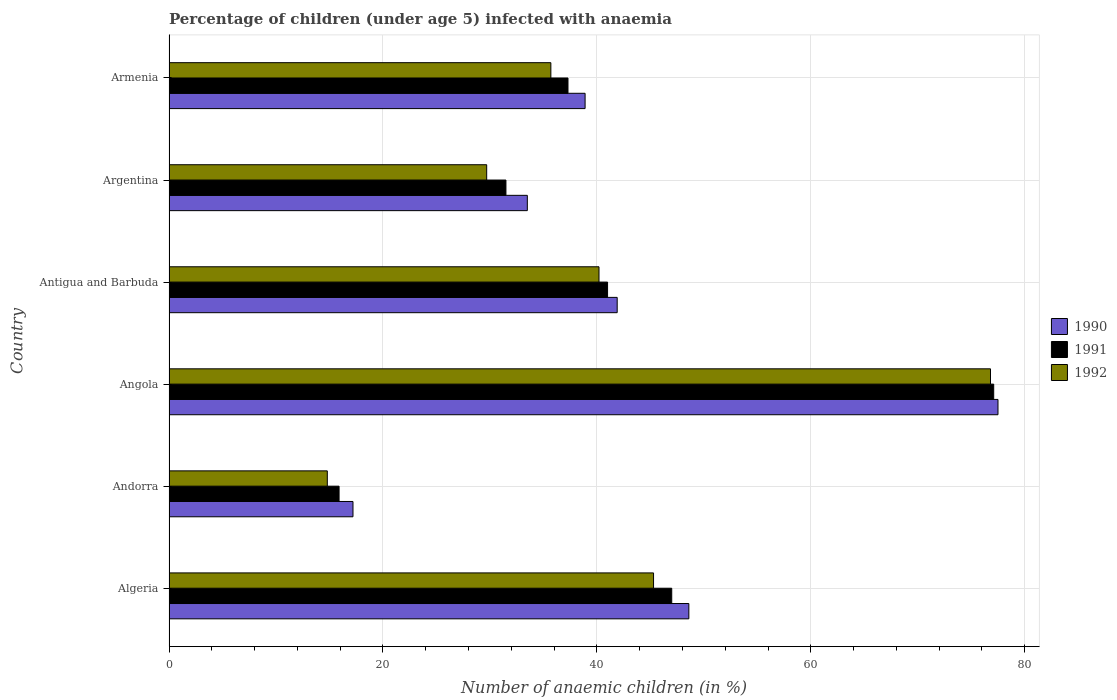How many groups of bars are there?
Your answer should be very brief. 6. How many bars are there on the 6th tick from the top?
Give a very brief answer. 3. What is the percentage of children infected with anaemia in in 1992 in Argentina?
Make the answer very short. 29.7. Across all countries, what is the maximum percentage of children infected with anaemia in in 1992?
Offer a terse response. 76.8. Across all countries, what is the minimum percentage of children infected with anaemia in in 1990?
Keep it short and to the point. 17.2. In which country was the percentage of children infected with anaemia in in 1990 maximum?
Keep it short and to the point. Angola. In which country was the percentage of children infected with anaemia in in 1992 minimum?
Provide a short and direct response. Andorra. What is the total percentage of children infected with anaemia in in 1990 in the graph?
Offer a very short reply. 257.6. What is the difference between the percentage of children infected with anaemia in in 1990 in Algeria and that in Armenia?
Provide a short and direct response. 9.7. What is the difference between the percentage of children infected with anaemia in in 1992 in Antigua and Barbuda and the percentage of children infected with anaemia in in 1990 in Angola?
Make the answer very short. -37.3. What is the average percentage of children infected with anaemia in in 1991 per country?
Give a very brief answer. 41.63. What is the difference between the percentage of children infected with anaemia in in 1990 and percentage of children infected with anaemia in in 1991 in Antigua and Barbuda?
Give a very brief answer. 0.9. In how many countries, is the percentage of children infected with anaemia in in 1990 greater than 24 %?
Give a very brief answer. 5. What is the ratio of the percentage of children infected with anaemia in in 1990 in Andorra to that in Angola?
Ensure brevity in your answer.  0.22. What is the difference between the highest and the second highest percentage of children infected with anaemia in in 1991?
Give a very brief answer. 30.1. What is the difference between the highest and the lowest percentage of children infected with anaemia in in 1991?
Your answer should be very brief. 61.2. In how many countries, is the percentage of children infected with anaemia in in 1992 greater than the average percentage of children infected with anaemia in in 1992 taken over all countries?
Make the answer very short. 2. What does the 1st bar from the top in Angola represents?
Provide a short and direct response. 1992. How many bars are there?
Keep it short and to the point. 18. How many countries are there in the graph?
Give a very brief answer. 6. Does the graph contain any zero values?
Offer a terse response. No. Does the graph contain grids?
Your response must be concise. Yes. Where does the legend appear in the graph?
Keep it short and to the point. Center right. How many legend labels are there?
Ensure brevity in your answer.  3. How are the legend labels stacked?
Your response must be concise. Vertical. What is the title of the graph?
Give a very brief answer. Percentage of children (under age 5) infected with anaemia. What is the label or title of the X-axis?
Your answer should be very brief. Number of anaemic children (in %). What is the Number of anaemic children (in %) of 1990 in Algeria?
Offer a terse response. 48.6. What is the Number of anaemic children (in %) of 1991 in Algeria?
Ensure brevity in your answer.  47. What is the Number of anaemic children (in %) in 1992 in Algeria?
Your answer should be compact. 45.3. What is the Number of anaemic children (in %) in 1990 in Andorra?
Provide a short and direct response. 17.2. What is the Number of anaemic children (in %) in 1991 in Andorra?
Your response must be concise. 15.9. What is the Number of anaemic children (in %) in 1990 in Angola?
Make the answer very short. 77.5. What is the Number of anaemic children (in %) of 1991 in Angola?
Your answer should be compact. 77.1. What is the Number of anaemic children (in %) in 1992 in Angola?
Make the answer very short. 76.8. What is the Number of anaemic children (in %) of 1990 in Antigua and Barbuda?
Ensure brevity in your answer.  41.9. What is the Number of anaemic children (in %) of 1991 in Antigua and Barbuda?
Offer a very short reply. 41. What is the Number of anaemic children (in %) of 1992 in Antigua and Barbuda?
Offer a terse response. 40.2. What is the Number of anaemic children (in %) in 1990 in Argentina?
Your answer should be compact. 33.5. What is the Number of anaemic children (in %) of 1991 in Argentina?
Your answer should be very brief. 31.5. What is the Number of anaemic children (in %) in 1992 in Argentina?
Keep it short and to the point. 29.7. What is the Number of anaemic children (in %) in 1990 in Armenia?
Offer a very short reply. 38.9. What is the Number of anaemic children (in %) in 1991 in Armenia?
Ensure brevity in your answer.  37.3. What is the Number of anaemic children (in %) in 1992 in Armenia?
Provide a succinct answer. 35.7. Across all countries, what is the maximum Number of anaemic children (in %) of 1990?
Provide a succinct answer. 77.5. Across all countries, what is the maximum Number of anaemic children (in %) in 1991?
Make the answer very short. 77.1. Across all countries, what is the maximum Number of anaemic children (in %) in 1992?
Provide a succinct answer. 76.8. What is the total Number of anaemic children (in %) of 1990 in the graph?
Give a very brief answer. 257.6. What is the total Number of anaemic children (in %) of 1991 in the graph?
Make the answer very short. 249.8. What is the total Number of anaemic children (in %) in 1992 in the graph?
Offer a very short reply. 242.5. What is the difference between the Number of anaemic children (in %) of 1990 in Algeria and that in Andorra?
Your answer should be compact. 31.4. What is the difference between the Number of anaemic children (in %) of 1991 in Algeria and that in Andorra?
Your answer should be very brief. 31.1. What is the difference between the Number of anaemic children (in %) of 1992 in Algeria and that in Andorra?
Give a very brief answer. 30.5. What is the difference between the Number of anaemic children (in %) of 1990 in Algeria and that in Angola?
Offer a terse response. -28.9. What is the difference between the Number of anaemic children (in %) in 1991 in Algeria and that in Angola?
Provide a short and direct response. -30.1. What is the difference between the Number of anaemic children (in %) of 1992 in Algeria and that in Angola?
Provide a short and direct response. -31.5. What is the difference between the Number of anaemic children (in %) of 1991 in Algeria and that in Antigua and Barbuda?
Your answer should be very brief. 6. What is the difference between the Number of anaemic children (in %) of 1990 in Algeria and that in Argentina?
Your answer should be compact. 15.1. What is the difference between the Number of anaemic children (in %) in 1991 in Algeria and that in Argentina?
Make the answer very short. 15.5. What is the difference between the Number of anaemic children (in %) of 1992 in Algeria and that in Argentina?
Make the answer very short. 15.6. What is the difference between the Number of anaemic children (in %) of 1990 in Algeria and that in Armenia?
Your response must be concise. 9.7. What is the difference between the Number of anaemic children (in %) in 1991 in Algeria and that in Armenia?
Offer a terse response. 9.7. What is the difference between the Number of anaemic children (in %) of 1992 in Algeria and that in Armenia?
Provide a short and direct response. 9.6. What is the difference between the Number of anaemic children (in %) in 1990 in Andorra and that in Angola?
Offer a very short reply. -60.3. What is the difference between the Number of anaemic children (in %) of 1991 in Andorra and that in Angola?
Your response must be concise. -61.2. What is the difference between the Number of anaemic children (in %) in 1992 in Andorra and that in Angola?
Offer a terse response. -62. What is the difference between the Number of anaemic children (in %) of 1990 in Andorra and that in Antigua and Barbuda?
Keep it short and to the point. -24.7. What is the difference between the Number of anaemic children (in %) of 1991 in Andorra and that in Antigua and Barbuda?
Keep it short and to the point. -25.1. What is the difference between the Number of anaemic children (in %) of 1992 in Andorra and that in Antigua and Barbuda?
Offer a terse response. -25.4. What is the difference between the Number of anaemic children (in %) in 1990 in Andorra and that in Argentina?
Keep it short and to the point. -16.3. What is the difference between the Number of anaemic children (in %) in 1991 in Andorra and that in Argentina?
Offer a terse response. -15.6. What is the difference between the Number of anaemic children (in %) of 1992 in Andorra and that in Argentina?
Offer a terse response. -14.9. What is the difference between the Number of anaemic children (in %) in 1990 in Andorra and that in Armenia?
Make the answer very short. -21.7. What is the difference between the Number of anaemic children (in %) of 1991 in Andorra and that in Armenia?
Ensure brevity in your answer.  -21.4. What is the difference between the Number of anaemic children (in %) of 1992 in Andorra and that in Armenia?
Keep it short and to the point. -20.9. What is the difference between the Number of anaemic children (in %) of 1990 in Angola and that in Antigua and Barbuda?
Your answer should be very brief. 35.6. What is the difference between the Number of anaemic children (in %) of 1991 in Angola and that in Antigua and Barbuda?
Provide a short and direct response. 36.1. What is the difference between the Number of anaemic children (in %) in 1992 in Angola and that in Antigua and Barbuda?
Provide a short and direct response. 36.6. What is the difference between the Number of anaemic children (in %) in 1991 in Angola and that in Argentina?
Provide a short and direct response. 45.6. What is the difference between the Number of anaemic children (in %) of 1992 in Angola and that in Argentina?
Provide a succinct answer. 47.1. What is the difference between the Number of anaemic children (in %) in 1990 in Angola and that in Armenia?
Offer a very short reply. 38.6. What is the difference between the Number of anaemic children (in %) in 1991 in Angola and that in Armenia?
Make the answer very short. 39.8. What is the difference between the Number of anaemic children (in %) in 1992 in Angola and that in Armenia?
Provide a succinct answer. 41.1. What is the difference between the Number of anaemic children (in %) of 1990 in Antigua and Barbuda and that in Argentina?
Provide a short and direct response. 8.4. What is the difference between the Number of anaemic children (in %) of 1991 in Antigua and Barbuda and that in Argentina?
Keep it short and to the point. 9.5. What is the difference between the Number of anaemic children (in %) of 1992 in Antigua and Barbuda and that in Argentina?
Give a very brief answer. 10.5. What is the difference between the Number of anaemic children (in %) of 1990 in Antigua and Barbuda and that in Armenia?
Your answer should be very brief. 3. What is the difference between the Number of anaemic children (in %) in 1991 in Antigua and Barbuda and that in Armenia?
Keep it short and to the point. 3.7. What is the difference between the Number of anaemic children (in %) of 1992 in Argentina and that in Armenia?
Your answer should be very brief. -6. What is the difference between the Number of anaemic children (in %) in 1990 in Algeria and the Number of anaemic children (in %) in 1991 in Andorra?
Provide a short and direct response. 32.7. What is the difference between the Number of anaemic children (in %) of 1990 in Algeria and the Number of anaemic children (in %) of 1992 in Andorra?
Offer a terse response. 33.8. What is the difference between the Number of anaemic children (in %) in 1991 in Algeria and the Number of anaemic children (in %) in 1992 in Andorra?
Make the answer very short. 32.2. What is the difference between the Number of anaemic children (in %) of 1990 in Algeria and the Number of anaemic children (in %) of 1991 in Angola?
Give a very brief answer. -28.5. What is the difference between the Number of anaemic children (in %) in 1990 in Algeria and the Number of anaemic children (in %) in 1992 in Angola?
Make the answer very short. -28.2. What is the difference between the Number of anaemic children (in %) of 1991 in Algeria and the Number of anaemic children (in %) of 1992 in Angola?
Your answer should be compact. -29.8. What is the difference between the Number of anaemic children (in %) in 1990 in Algeria and the Number of anaemic children (in %) in 1991 in Antigua and Barbuda?
Give a very brief answer. 7.6. What is the difference between the Number of anaemic children (in %) of 1990 in Algeria and the Number of anaemic children (in %) of 1992 in Antigua and Barbuda?
Offer a very short reply. 8.4. What is the difference between the Number of anaemic children (in %) of 1990 in Algeria and the Number of anaemic children (in %) of 1991 in Argentina?
Provide a short and direct response. 17.1. What is the difference between the Number of anaemic children (in %) of 1991 in Algeria and the Number of anaemic children (in %) of 1992 in Argentina?
Offer a terse response. 17.3. What is the difference between the Number of anaemic children (in %) in 1990 in Andorra and the Number of anaemic children (in %) in 1991 in Angola?
Your answer should be very brief. -59.9. What is the difference between the Number of anaemic children (in %) in 1990 in Andorra and the Number of anaemic children (in %) in 1992 in Angola?
Offer a very short reply. -59.6. What is the difference between the Number of anaemic children (in %) of 1991 in Andorra and the Number of anaemic children (in %) of 1992 in Angola?
Give a very brief answer. -60.9. What is the difference between the Number of anaemic children (in %) of 1990 in Andorra and the Number of anaemic children (in %) of 1991 in Antigua and Barbuda?
Make the answer very short. -23.8. What is the difference between the Number of anaemic children (in %) of 1990 in Andorra and the Number of anaemic children (in %) of 1992 in Antigua and Barbuda?
Ensure brevity in your answer.  -23. What is the difference between the Number of anaemic children (in %) of 1991 in Andorra and the Number of anaemic children (in %) of 1992 in Antigua and Barbuda?
Offer a very short reply. -24.3. What is the difference between the Number of anaemic children (in %) of 1990 in Andorra and the Number of anaemic children (in %) of 1991 in Argentina?
Offer a terse response. -14.3. What is the difference between the Number of anaemic children (in %) of 1990 in Andorra and the Number of anaemic children (in %) of 1991 in Armenia?
Give a very brief answer. -20.1. What is the difference between the Number of anaemic children (in %) in 1990 in Andorra and the Number of anaemic children (in %) in 1992 in Armenia?
Offer a terse response. -18.5. What is the difference between the Number of anaemic children (in %) of 1991 in Andorra and the Number of anaemic children (in %) of 1992 in Armenia?
Keep it short and to the point. -19.8. What is the difference between the Number of anaemic children (in %) in 1990 in Angola and the Number of anaemic children (in %) in 1991 in Antigua and Barbuda?
Offer a very short reply. 36.5. What is the difference between the Number of anaemic children (in %) of 1990 in Angola and the Number of anaemic children (in %) of 1992 in Antigua and Barbuda?
Offer a terse response. 37.3. What is the difference between the Number of anaemic children (in %) in 1991 in Angola and the Number of anaemic children (in %) in 1992 in Antigua and Barbuda?
Your answer should be very brief. 36.9. What is the difference between the Number of anaemic children (in %) of 1990 in Angola and the Number of anaemic children (in %) of 1992 in Argentina?
Offer a very short reply. 47.8. What is the difference between the Number of anaemic children (in %) in 1991 in Angola and the Number of anaemic children (in %) in 1992 in Argentina?
Keep it short and to the point. 47.4. What is the difference between the Number of anaemic children (in %) in 1990 in Angola and the Number of anaemic children (in %) in 1991 in Armenia?
Your response must be concise. 40.2. What is the difference between the Number of anaemic children (in %) of 1990 in Angola and the Number of anaemic children (in %) of 1992 in Armenia?
Give a very brief answer. 41.8. What is the difference between the Number of anaemic children (in %) of 1991 in Angola and the Number of anaemic children (in %) of 1992 in Armenia?
Your answer should be very brief. 41.4. What is the difference between the Number of anaemic children (in %) of 1990 in Antigua and Barbuda and the Number of anaemic children (in %) of 1992 in Argentina?
Your response must be concise. 12.2. What is the difference between the Number of anaemic children (in %) of 1990 in Antigua and Barbuda and the Number of anaemic children (in %) of 1992 in Armenia?
Your answer should be compact. 6.2. What is the difference between the Number of anaemic children (in %) in 1990 in Argentina and the Number of anaemic children (in %) in 1991 in Armenia?
Your response must be concise. -3.8. What is the difference between the Number of anaemic children (in %) of 1991 in Argentina and the Number of anaemic children (in %) of 1992 in Armenia?
Ensure brevity in your answer.  -4.2. What is the average Number of anaemic children (in %) in 1990 per country?
Offer a very short reply. 42.93. What is the average Number of anaemic children (in %) in 1991 per country?
Provide a short and direct response. 41.63. What is the average Number of anaemic children (in %) in 1992 per country?
Make the answer very short. 40.42. What is the difference between the Number of anaemic children (in %) in 1991 and Number of anaemic children (in %) in 1992 in Algeria?
Provide a succinct answer. 1.7. What is the difference between the Number of anaemic children (in %) of 1990 and Number of anaemic children (in %) of 1991 in Andorra?
Provide a succinct answer. 1.3. What is the difference between the Number of anaemic children (in %) in 1990 and Number of anaemic children (in %) in 1991 in Antigua and Barbuda?
Your response must be concise. 0.9. What is the difference between the Number of anaemic children (in %) in 1990 and Number of anaemic children (in %) in 1992 in Antigua and Barbuda?
Keep it short and to the point. 1.7. What is the difference between the Number of anaemic children (in %) of 1991 and Number of anaemic children (in %) of 1992 in Argentina?
Make the answer very short. 1.8. What is the difference between the Number of anaemic children (in %) in 1990 and Number of anaemic children (in %) in 1991 in Armenia?
Make the answer very short. 1.6. What is the difference between the Number of anaemic children (in %) of 1990 and Number of anaemic children (in %) of 1992 in Armenia?
Give a very brief answer. 3.2. What is the ratio of the Number of anaemic children (in %) in 1990 in Algeria to that in Andorra?
Provide a succinct answer. 2.83. What is the ratio of the Number of anaemic children (in %) of 1991 in Algeria to that in Andorra?
Your response must be concise. 2.96. What is the ratio of the Number of anaemic children (in %) of 1992 in Algeria to that in Andorra?
Provide a short and direct response. 3.06. What is the ratio of the Number of anaemic children (in %) of 1990 in Algeria to that in Angola?
Ensure brevity in your answer.  0.63. What is the ratio of the Number of anaemic children (in %) of 1991 in Algeria to that in Angola?
Your answer should be compact. 0.61. What is the ratio of the Number of anaemic children (in %) of 1992 in Algeria to that in Angola?
Your answer should be compact. 0.59. What is the ratio of the Number of anaemic children (in %) in 1990 in Algeria to that in Antigua and Barbuda?
Your response must be concise. 1.16. What is the ratio of the Number of anaemic children (in %) in 1991 in Algeria to that in Antigua and Barbuda?
Provide a short and direct response. 1.15. What is the ratio of the Number of anaemic children (in %) in 1992 in Algeria to that in Antigua and Barbuda?
Make the answer very short. 1.13. What is the ratio of the Number of anaemic children (in %) of 1990 in Algeria to that in Argentina?
Provide a short and direct response. 1.45. What is the ratio of the Number of anaemic children (in %) in 1991 in Algeria to that in Argentina?
Provide a succinct answer. 1.49. What is the ratio of the Number of anaemic children (in %) in 1992 in Algeria to that in Argentina?
Provide a short and direct response. 1.53. What is the ratio of the Number of anaemic children (in %) in 1990 in Algeria to that in Armenia?
Give a very brief answer. 1.25. What is the ratio of the Number of anaemic children (in %) of 1991 in Algeria to that in Armenia?
Make the answer very short. 1.26. What is the ratio of the Number of anaemic children (in %) in 1992 in Algeria to that in Armenia?
Your response must be concise. 1.27. What is the ratio of the Number of anaemic children (in %) of 1990 in Andorra to that in Angola?
Your response must be concise. 0.22. What is the ratio of the Number of anaemic children (in %) of 1991 in Andorra to that in Angola?
Make the answer very short. 0.21. What is the ratio of the Number of anaemic children (in %) in 1992 in Andorra to that in Angola?
Your response must be concise. 0.19. What is the ratio of the Number of anaemic children (in %) in 1990 in Andorra to that in Antigua and Barbuda?
Offer a terse response. 0.41. What is the ratio of the Number of anaemic children (in %) of 1991 in Andorra to that in Antigua and Barbuda?
Provide a succinct answer. 0.39. What is the ratio of the Number of anaemic children (in %) in 1992 in Andorra to that in Antigua and Barbuda?
Provide a short and direct response. 0.37. What is the ratio of the Number of anaemic children (in %) of 1990 in Andorra to that in Argentina?
Your answer should be compact. 0.51. What is the ratio of the Number of anaemic children (in %) in 1991 in Andorra to that in Argentina?
Give a very brief answer. 0.5. What is the ratio of the Number of anaemic children (in %) of 1992 in Andorra to that in Argentina?
Your response must be concise. 0.5. What is the ratio of the Number of anaemic children (in %) of 1990 in Andorra to that in Armenia?
Make the answer very short. 0.44. What is the ratio of the Number of anaemic children (in %) of 1991 in Andorra to that in Armenia?
Your answer should be very brief. 0.43. What is the ratio of the Number of anaemic children (in %) of 1992 in Andorra to that in Armenia?
Make the answer very short. 0.41. What is the ratio of the Number of anaemic children (in %) of 1990 in Angola to that in Antigua and Barbuda?
Give a very brief answer. 1.85. What is the ratio of the Number of anaemic children (in %) of 1991 in Angola to that in Antigua and Barbuda?
Ensure brevity in your answer.  1.88. What is the ratio of the Number of anaemic children (in %) of 1992 in Angola to that in Antigua and Barbuda?
Keep it short and to the point. 1.91. What is the ratio of the Number of anaemic children (in %) in 1990 in Angola to that in Argentina?
Give a very brief answer. 2.31. What is the ratio of the Number of anaemic children (in %) in 1991 in Angola to that in Argentina?
Provide a succinct answer. 2.45. What is the ratio of the Number of anaemic children (in %) in 1992 in Angola to that in Argentina?
Your answer should be very brief. 2.59. What is the ratio of the Number of anaemic children (in %) of 1990 in Angola to that in Armenia?
Make the answer very short. 1.99. What is the ratio of the Number of anaemic children (in %) in 1991 in Angola to that in Armenia?
Provide a succinct answer. 2.07. What is the ratio of the Number of anaemic children (in %) in 1992 in Angola to that in Armenia?
Your answer should be compact. 2.15. What is the ratio of the Number of anaemic children (in %) in 1990 in Antigua and Barbuda to that in Argentina?
Provide a succinct answer. 1.25. What is the ratio of the Number of anaemic children (in %) in 1991 in Antigua and Barbuda to that in Argentina?
Your response must be concise. 1.3. What is the ratio of the Number of anaemic children (in %) of 1992 in Antigua and Barbuda to that in Argentina?
Your answer should be compact. 1.35. What is the ratio of the Number of anaemic children (in %) in 1990 in Antigua and Barbuda to that in Armenia?
Provide a succinct answer. 1.08. What is the ratio of the Number of anaemic children (in %) in 1991 in Antigua and Barbuda to that in Armenia?
Offer a terse response. 1.1. What is the ratio of the Number of anaemic children (in %) of 1992 in Antigua and Barbuda to that in Armenia?
Ensure brevity in your answer.  1.13. What is the ratio of the Number of anaemic children (in %) in 1990 in Argentina to that in Armenia?
Offer a very short reply. 0.86. What is the ratio of the Number of anaemic children (in %) of 1991 in Argentina to that in Armenia?
Offer a very short reply. 0.84. What is the ratio of the Number of anaemic children (in %) of 1992 in Argentina to that in Armenia?
Provide a succinct answer. 0.83. What is the difference between the highest and the second highest Number of anaemic children (in %) of 1990?
Your response must be concise. 28.9. What is the difference between the highest and the second highest Number of anaemic children (in %) of 1991?
Give a very brief answer. 30.1. What is the difference between the highest and the second highest Number of anaemic children (in %) in 1992?
Provide a short and direct response. 31.5. What is the difference between the highest and the lowest Number of anaemic children (in %) in 1990?
Your answer should be compact. 60.3. What is the difference between the highest and the lowest Number of anaemic children (in %) in 1991?
Provide a succinct answer. 61.2. 